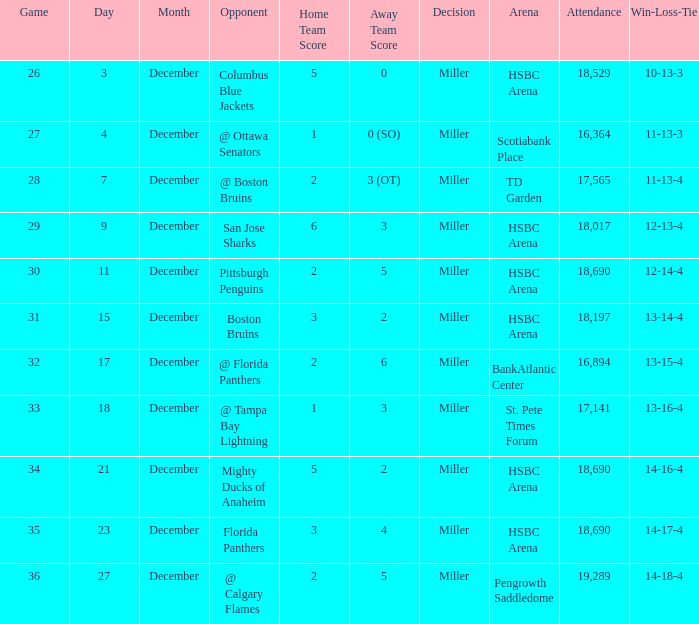Name the december for record 14-17-4 23.0. 